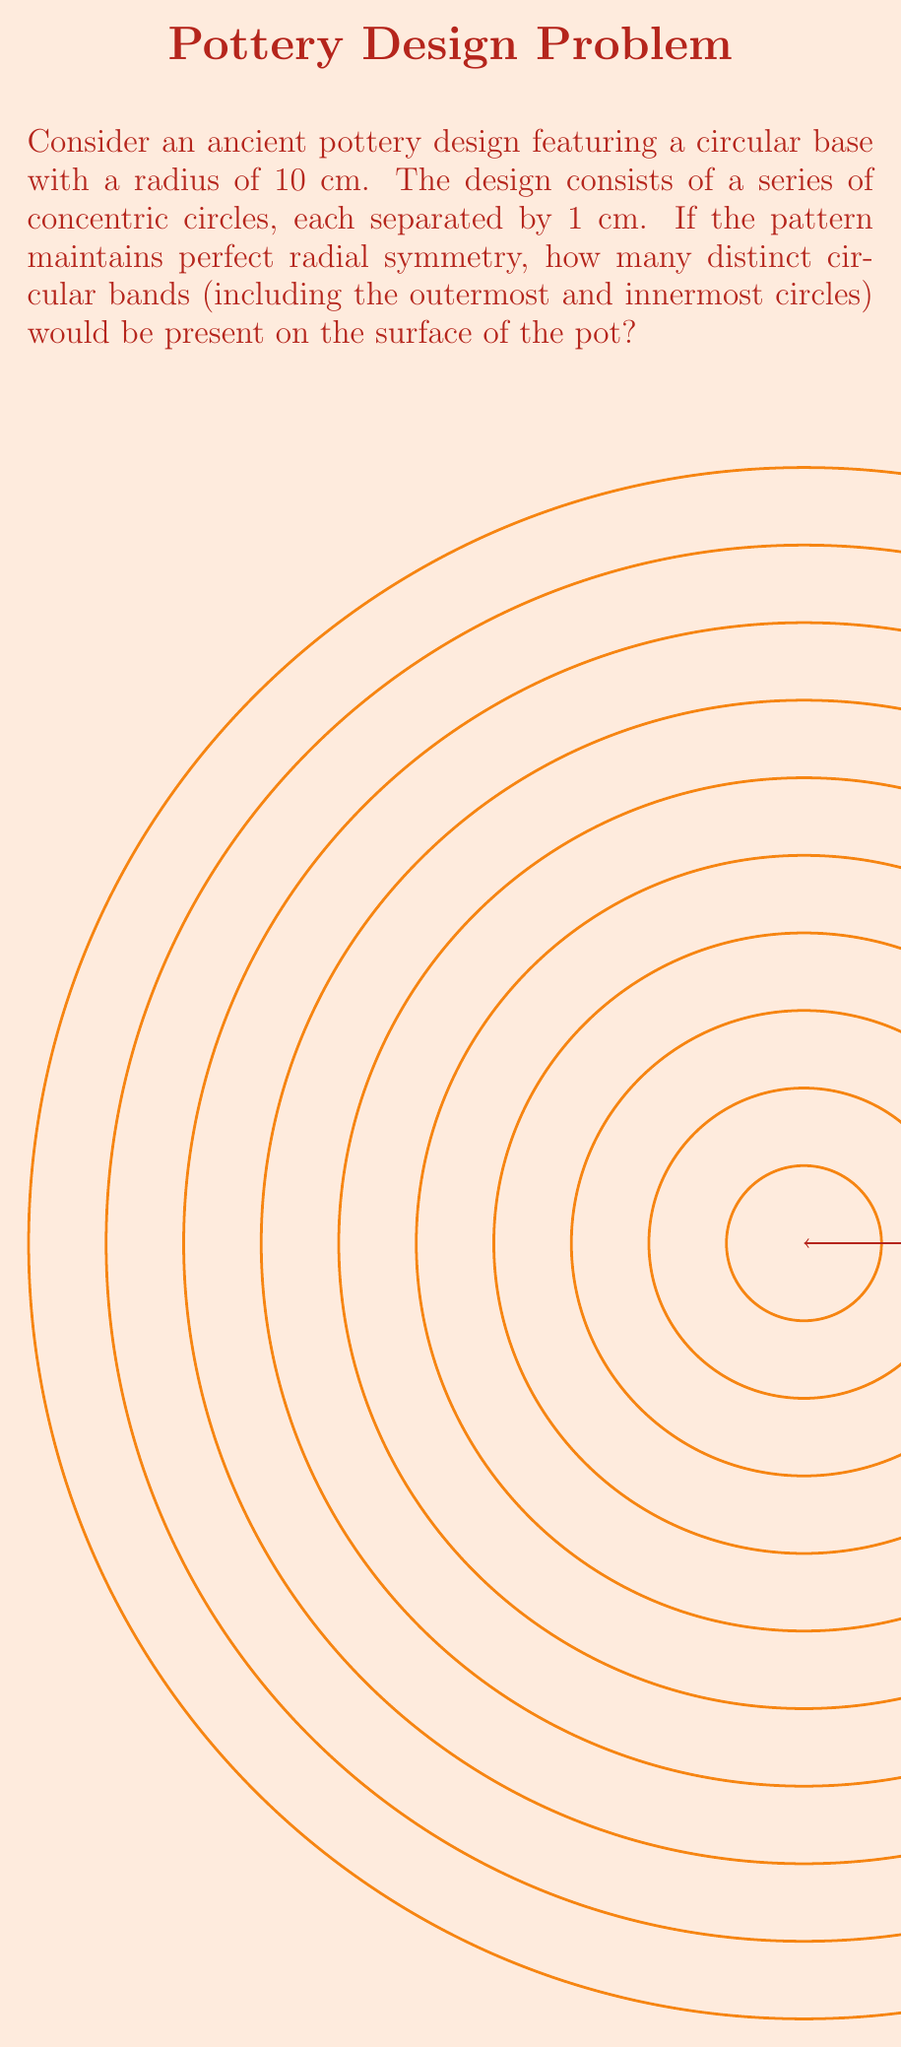Help me with this question. To solve this problem, we need to follow these steps:

1) First, recognize that the outermost circle has a radius of 10 cm, and this forms the first band.

2) Each subsequent band is formed by a circle with a radius 1 cm smaller than the previous one.

3) We can represent this mathematically as an arithmetic sequence:
   $$a_n = 10 - (n-1)$$
   where $a_n$ is the radius of the nth circle, and n is the number of the circle counting from the outside in.

4) The sequence continues until we reach the innermost circle. The innermost circle will have a radius of 0 cm (effectively a point at the center).

5) To find the number of circles, we need to solve:
   $$0 = 10 - (n-1)$$
   $$n-1 = 10$$
   $$n = 11$$

6) Therefore, there are 11 circles in total, including the outermost circle (radius 10 cm) and the innermost point (radius 0 cm).

7) Each of these circles forms a distinct band on the surface of the pot, so the number of bands is equal to the number of circles.

This design demonstrates perfect radial symmetry, as each band is equidistant from its neighbors and centered around the same point, a principle often observed in ancient pottery designs.
Answer: 11 bands 